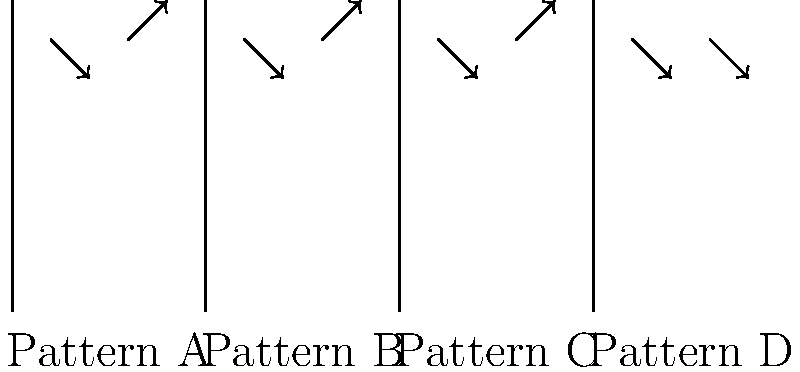Which of the strumming patterns shown above represents the common "Down-Up-Down-Up" pattern often used in contemporary ukulele playing? Let's analyze each pattern step-by-step:

1. Pattern A: This shows a Down-Up strumming pattern. The first arrow points downward, and the second points upward.

2. Pattern B: This also shows a Down-Up strumming pattern, identical to Pattern A.

3. Pattern C: This again shows a Down-Up strumming pattern, identical to Patterns A and B.

4. Pattern D: This shows a Down-Down strumming pattern. Both arrows are pointing downward.

The "Down-Up-Down-Up" pattern is characterized by alternating downward and upward strums. This creates a steady, even rhythm that's commonly used in many contemporary ukulele songs.

Among the given patterns, A, B, and C all show this alternating Down-Up pattern. However, the question asks for the complete "Down-Up-Down-Up" sequence, which would require two consecutive Down-Up patterns.

Pattern B is the only one that shows two complete Down-Up patterns in succession, effectively representing the "Down-Up-Down-Up" strumming pattern.
Answer: Pattern B 